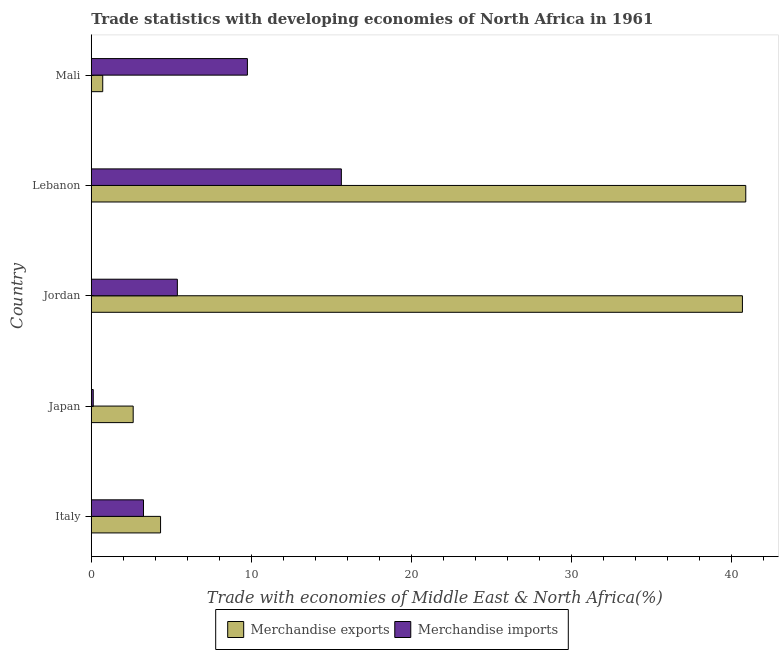How many groups of bars are there?
Keep it short and to the point. 5. Are the number of bars per tick equal to the number of legend labels?
Your response must be concise. Yes. How many bars are there on the 2nd tick from the top?
Your response must be concise. 2. What is the label of the 2nd group of bars from the top?
Make the answer very short. Lebanon. What is the merchandise exports in Japan?
Give a very brief answer. 2.62. Across all countries, what is the maximum merchandise imports?
Your answer should be very brief. 15.62. Across all countries, what is the minimum merchandise exports?
Give a very brief answer. 0.71. In which country was the merchandise imports maximum?
Ensure brevity in your answer.  Lebanon. What is the total merchandise imports in the graph?
Provide a succinct answer. 34.14. What is the difference between the merchandise imports in Italy and that in Lebanon?
Offer a terse response. -12.36. What is the difference between the merchandise exports in Lebanon and the merchandise imports in Italy?
Provide a short and direct response. 37.63. What is the average merchandise exports per country?
Offer a terse response. 17.84. What is the difference between the merchandise imports and merchandise exports in Italy?
Offer a very short reply. -1.07. What is the ratio of the merchandise exports in Italy to that in Jordan?
Ensure brevity in your answer.  0.11. Is the merchandise imports in Italy less than that in Japan?
Give a very brief answer. No. Is the difference between the merchandise imports in Lebanon and Mali greater than the difference between the merchandise exports in Lebanon and Mali?
Provide a succinct answer. No. What is the difference between the highest and the second highest merchandise imports?
Ensure brevity in your answer.  5.87. What does the 2nd bar from the bottom in Lebanon represents?
Ensure brevity in your answer.  Merchandise imports. How many bars are there?
Your response must be concise. 10. How many countries are there in the graph?
Give a very brief answer. 5. Are the values on the major ticks of X-axis written in scientific E-notation?
Provide a succinct answer. No. Does the graph contain grids?
Keep it short and to the point. No. Where does the legend appear in the graph?
Provide a short and direct response. Bottom center. What is the title of the graph?
Your answer should be compact. Trade statistics with developing economies of North Africa in 1961. Does "Under-5(female)" appear as one of the legend labels in the graph?
Make the answer very short. No. What is the label or title of the X-axis?
Ensure brevity in your answer.  Trade with economies of Middle East & North Africa(%). What is the label or title of the Y-axis?
Ensure brevity in your answer.  Country. What is the Trade with economies of Middle East & North Africa(%) of Merchandise exports in Italy?
Offer a terse response. 4.33. What is the Trade with economies of Middle East & North Africa(%) in Merchandise imports in Italy?
Your response must be concise. 3.26. What is the Trade with economies of Middle East & North Africa(%) in Merchandise exports in Japan?
Your answer should be very brief. 2.62. What is the Trade with economies of Middle East & North Africa(%) of Merchandise imports in Japan?
Ensure brevity in your answer.  0.12. What is the Trade with economies of Middle East & North Africa(%) in Merchandise exports in Jordan?
Provide a succinct answer. 40.68. What is the Trade with economies of Middle East & North Africa(%) of Merchandise imports in Jordan?
Your response must be concise. 5.38. What is the Trade with economies of Middle East & North Africa(%) of Merchandise exports in Lebanon?
Keep it short and to the point. 40.89. What is the Trade with economies of Middle East & North Africa(%) of Merchandise imports in Lebanon?
Provide a short and direct response. 15.62. What is the Trade with economies of Middle East & North Africa(%) of Merchandise exports in Mali?
Give a very brief answer. 0.71. What is the Trade with economies of Middle East & North Africa(%) in Merchandise imports in Mali?
Your answer should be compact. 9.75. Across all countries, what is the maximum Trade with economies of Middle East & North Africa(%) in Merchandise exports?
Your answer should be very brief. 40.89. Across all countries, what is the maximum Trade with economies of Middle East & North Africa(%) of Merchandise imports?
Offer a terse response. 15.62. Across all countries, what is the minimum Trade with economies of Middle East & North Africa(%) in Merchandise exports?
Provide a short and direct response. 0.71. Across all countries, what is the minimum Trade with economies of Middle East & North Africa(%) in Merchandise imports?
Make the answer very short. 0.12. What is the total Trade with economies of Middle East & North Africa(%) of Merchandise exports in the graph?
Offer a terse response. 89.22. What is the total Trade with economies of Middle East & North Africa(%) of Merchandise imports in the graph?
Ensure brevity in your answer.  34.14. What is the difference between the Trade with economies of Middle East & North Africa(%) of Merchandise exports in Italy and that in Japan?
Your answer should be compact. 1.71. What is the difference between the Trade with economies of Middle East & North Africa(%) of Merchandise imports in Italy and that in Japan?
Ensure brevity in your answer.  3.14. What is the difference between the Trade with economies of Middle East & North Africa(%) of Merchandise exports in Italy and that in Jordan?
Your answer should be compact. -36.35. What is the difference between the Trade with economies of Middle East & North Africa(%) in Merchandise imports in Italy and that in Jordan?
Your answer should be compact. -2.12. What is the difference between the Trade with economies of Middle East & North Africa(%) in Merchandise exports in Italy and that in Lebanon?
Offer a terse response. -36.56. What is the difference between the Trade with economies of Middle East & North Africa(%) in Merchandise imports in Italy and that in Lebanon?
Offer a very short reply. -12.36. What is the difference between the Trade with economies of Middle East & North Africa(%) in Merchandise exports in Italy and that in Mali?
Your answer should be very brief. 3.61. What is the difference between the Trade with economies of Middle East & North Africa(%) in Merchandise imports in Italy and that in Mali?
Make the answer very short. -6.49. What is the difference between the Trade with economies of Middle East & North Africa(%) of Merchandise exports in Japan and that in Jordan?
Your answer should be very brief. -38.06. What is the difference between the Trade with economies of Middle East & North Africa(%) in Merchandise imports in Japan and that in Jordan?
Your answer should be compact. -5.25. What is the difference between the Trade with economies of Middle East & North Africa(%) in Merchandise exports in Japan and that in Lebanon?
Your response must be concise. -38.27. What is the difference between the Trade with economies of Middle East & North Africa(%) in Merchandise imports in Japan and that in Lebanon?
Keep it short and to the point. -15.5. What is the difference between the Trade with economies of Middle East & North Africa(%) in Merchandise exports in Japan and that in Mali?
Make the answer very short. 1.9. What is the difference between the Trade with economies of Middle East & North Africa(%) of Merchandise imports in Japan and that in Mali?
Offer a very short reply. -9.63. What is the difference between the Trade with economies of Middle East & North Africa(%) in Merchandise exports in Jordan and that in Lebanon?
Your answer should be very brief. -0.21. What is the difference between the Trade with economies of Middle East & North Africa(%) in Merchandise imports in Jordan and that in Lebanon?
Offer a very short reply. -10.25. What is the difference between the Trade with economies of Middle East & North Africa(%) of Merchandise exports in Jordan and that in Mali?
Keep it short and to the point. 39.96. What is the difference between the Trade with economies of Middle East & North Africa(%) of Merchandise imports in Jordan and that in Mali?
Keep it short and to the point. -4.38. What is the difference between the Trade with economies of Middle East & North Africa(%) in Merchandise exports in Lebanon and that in Mali?
Make the answer very short. 40.17. What is the difference between the Trade with economies of Middle East & North Africa(%) of Merchandise imports in Lebanon and that in Mali?
Make the answer very short. 5.87. What is the difference between the Trade with economies of Middle East & North Africa(%) of Merchandise exports in Italy and the Trade with economies of Middle East & North Africa(%) of Merchandise imports in Japan?
Offer a very short reply. 4.2. What is the difference between the Trade with economies of Middle East & North Africa(%) of Merchandise exports in Italy and the Trade with economies of Middle East & North Africa(%) of Merchandise imports in Jordan?
Offer a terse response. -1.05. What is the difference between the Trade with economies of Middle East & North Africa(%) in Merchandise exports in Italy and the Trade with economies of Middle East & North Africa(%) in Merchandise imports in Lebanon?
Your answer should be compact. -11.3. What is the difference between the Trade with economies of Middle East & North Africa(%) in Merchandise exports in Italy and the Trade with economies of Middle East & North Africa(%) in Merchandise imports in Mali?
Offer a terse response. -5.43. What is the difference between the Trade with economies of Middle East & North Africa(%) of Merchandise exports in Japan and the Trade with economies of Middle East & North Africa(%) of Merchandise imports in Jordan?
Make the answer very short. -2.76. What is the difference between the Trade with economies of Middle East & North Africa(%) in Merchandise exports in Japan and the Trade with economies of Middle East & North Africa(%) in Merchandise imports in Lebanon?
Provide a succinct answer. -13.01. What is the difference between the Trade with economies of Middle East & North Africa(%) in Merchandise exports in Japan and the Trade with economies of Middle East & North Africa(%) in Merchandise imports in Mali?
Offer a very short reply. -7.14. What is the difference between the Trade with economies of Middle East & North Africa(%) in Merchandise exports in Jordan and the Trade with economies of Middle East & North Africa(%) in Merchandise imports in Lebanon?
Provide a short and direct response. 25.06. What is the difference between the Trade with economies of Middle East & North Africa(%) of Merchandise exports in Jordan and the Trade with economies of Middle East & North Africa(%) of Merchandise imports in Mali?
Make the answer very short. 30.92. What is the difference between the Trade with economies of Middle East & North Africa(%) in Merchandise exports in Lebanon and the Trade with economies of Middle East & North Africa(%) in Merchandise imports in Mali?
Provide a short and direct response. 31.13. What is the average Trade with economies of Middle East & North Africa(%) in Merchandise exports per country?
Your answer should be compact. 17.84. What is the average Trade with economies of Middle East & North Africa(%) in Merchandise imports per country?
Ensure brevity in your answer.  6.83. What is the difference between the Trade with economies of Middle East & North Africa(%) in Merchandise exports and Trade with economies of Middle East & North Africa(%) in Merchandise imports in Italy?
Give a very brief answer. 1.07. What is the difference between the Trade with economies of Middle East & North Africa(%) of Merchandise exports and Trade with economies of Middle East & North Africa(%) of Merchandise imports in Japan?
Your response must be concise. 2.49. What is the difference between the Trade with economies of Middle East & North Africa(%) in Merchandise exports and Trade with economies of Middle East & North Africa(%) in Merchandise imports in Jordan?
Your response must be concise. 35.3. What is the difference between the Trade with economies of Middle East & North Africa(%) of Merchandise exports and Trade with economies of Middle East & North Africa(%) of Merchandise imports in Lebanon?
Provide a short and direct response. 25.26. What is the difference between the Trade with economies of Middle East & North Africa(%) in Merchandise exports and Trade with economies of Middle East & North Africa(%) in Merchandise imports in Mali?
Provide a short and direct response. -9.04. What is the ratio of the Trade with economies of Middle East & North Africa(%) in Merchandise exports in Italy to that in Japan?
Provide a succinct answer. 1.65. What is the ratio of the Trade with economies of Middle East & North Africa(%) of Merchandise imports in Italy to that in Japan?
Offer a terse response. 26.66. What is the ratio of the Trade with economies of Middle East & North Africa(%) in Merchandise exports in Italy to that in Jordan?
Ensure brevity in your answer.  0.11. What is the ratio of the Trade with economies of Middle East & North Africa(%) of Merchandise imports in Italy to that in Jordan?
Make the answer very short. 0.61. What is the ratio of the Trade with economies of Middle East & North Africa(%) of Merchandise exports in Italy to that in Lebanon?
Make the answer very short. 0.11. What is the ratio of the Trade with economies of Middle East & North Africa(%) of Merchandise imports in Italy to that in Lebanon?
Make the answer very short. 0.21. What is the ratio of the Trade with economies of Middle East & North Africa(%) in Merchandise exports in Italy to that in Mali?
Offer a very short reply. 6.06. What is the ratio of the Trade with economies of Middle East & North Africa(%) in Merchandise imports in Italy to that in Mali?
Your answer should be very brief. 0.33. What is the ratio of the Trade with economies of Middle East & North Africa(%) of Merchandise exports in Japan to that in Jordan?
Give a very brief answer. 0.06. What is the ratio of the Trade with economies of Middle East & North Africa(%) of Merchandise imports in Japan to that in Jordan?
Keep it short and to the point. 0.02. What is the ratio of the Trade with economies of Middle East & North Africa(%) of Merchandise exports in Japan to that in Lebanon?
Your answer should be very brief. 0.06. What is the ratio of the Trade with economies of Middle East & North Africa(%) in Merchandise imports in Japan to that in Lebanon?
Make the answer very short. 0.01. What is the ratio of the Trade with economies of Middle East & North Africa(%) of Merchandise exports in Japan to that in Mali?
Your response must be concise. 3.66. What is the ratio of the Trade with economies of Middle East & North Africa(%) in Merchandise imports in Japan to that in Mali?
Provide a short and direct response. 0.01. What is the ratio of the Trade with economies of Middle East & North Africa(%) in Merchandise exports in Jordan to that in Lebanon?
Provide a short and direct response. 0.99. What is the ratio of the Trade with economies of Middle East & North Africa(%) of Merchandise imports in Jordan to that in Lebanon?
Your response must be concise. 0.34. What is the ratio of the Trade with economies of Middle East & North Africa(%) of Merchandise exports in Jordan to that in Mali?
Your answer should be very brief. 56.95. What is the ratio of the Trade with economies of Middle East & North Africa(%) in Merchandise imports in Jordan to that in Mali?
Make the answer very short. 0.55. What is the ratio of the Trade with economies of Middle East & North Africa(%) of Merchandise exports in Lebanon to that in Mali?
Provide a succinct answer. 57.24. What is the ratio of the Trade with economies of Middle East & North Africa(%) of Merchandise imports in Lebanon to that in Mali?
Offer a very short reply. 1.6. What is the difference between the highest and the second highest Trade with economies of Middle East & North Africa(%) of Merchandise exports?
Your answer should be very brief. 0.21. What is the difference between the highest and the second highest Trade with economies of Middle East & North Africa(%) in Merchandise imports?
Provide a succinct answer. 5.87. What is the difference between the highest and the lowest Trade with economies of Middle East & North Africa(%) of Merchandise exports?
Offer a terse response. 40.17. 